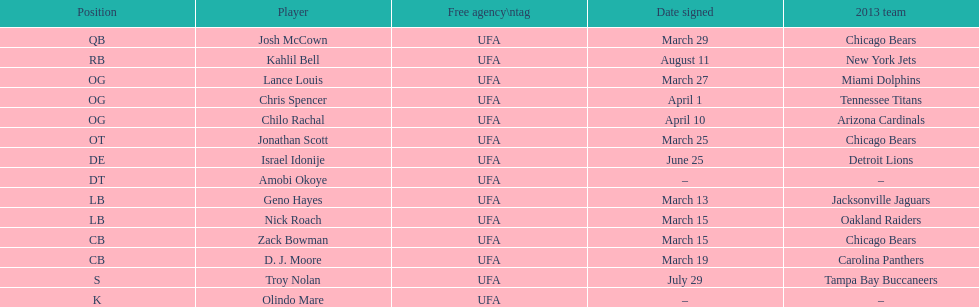What is the combined total of 2013 teams on the diagram? 10. 